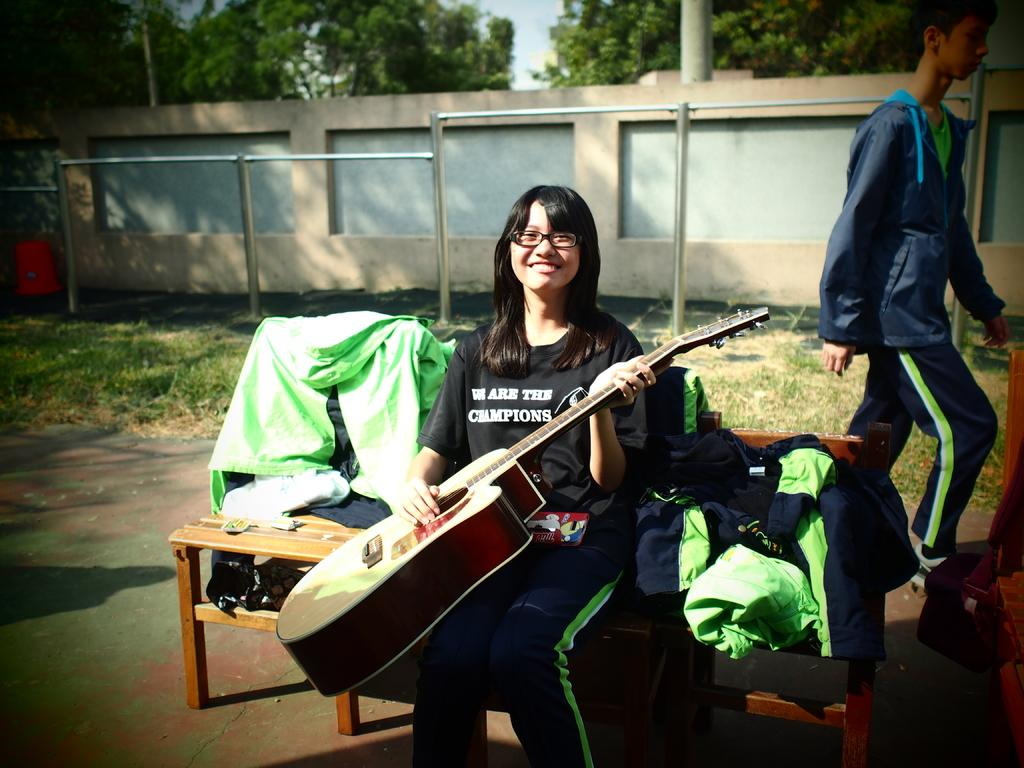Who is the main subject in the image? There is a woman in the image. What is the woman doing in the image? The woman is sitting on a chair and holding a guitar in her hand. Is there anyone else in the image? Yes, there is a man in the image. What is the man doing in the image? The man is standing at the back of the woman. What type of garden can be seen in the image? There is no garden present in the image. What color is the banana that the woman is holding? The woman is holding a guitar, not a banana, in the image. 